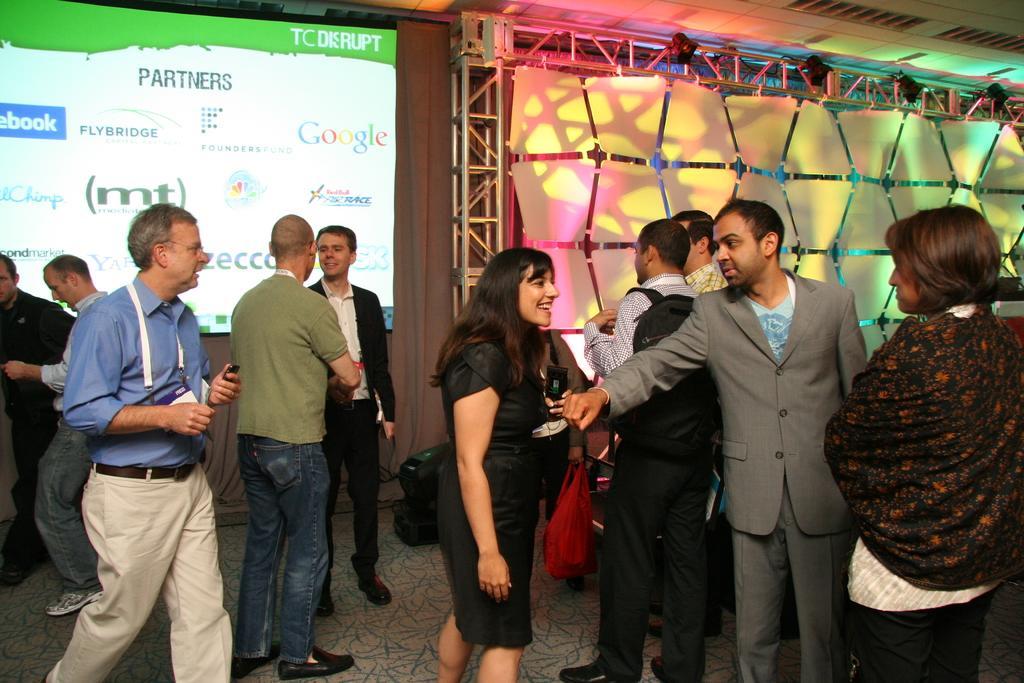Could you give a brief overview of what you see in this image? In this image, I can see a group of people are standing on the floor. In the background, I can see a screen, metal rods, focus lights and a rooftop. This image taken, maybe in a house. 